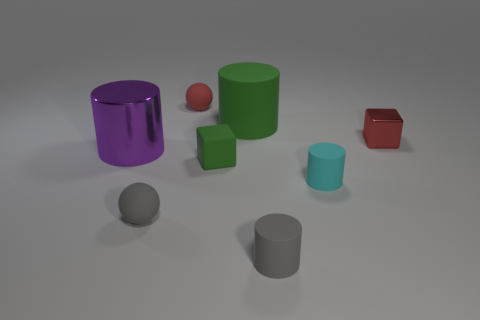Does the big shiny thing have the same shape as the tiny shiny object?
Ensure brevity in your answer.  No. What color is the matte cube that is the same size as the red matte sphere?
Your answer should be very brief. Green. The other cyan thing that is the same shape as the big matte object is what size?
Ensure brevity in your answer.  Small. The metal thing on the right side of the purple shiny thing has what shape?
Ensure brevity in your answer.  Cube. Do the big metallic object and the green rubber object behind the tiny green block have the same shape?
Offer a terse response. Yes. Are there the same number of large metallic things in front of the big purple cylinder and green rubber objects to the right of the shiny cube?
Your response must be concise. Yes. There is a rubber object that is the same color as the shiny cube; what is its shape?
Your answer should be compact. Sphere. There is a rubber thing to the left of the small red rubber thing; is its color the same as the metal thing that is behind the big purple metal object?
Ensure brevity in your answer.  No. Are there more small red things in front of the tiny red metallic object than tiny gray matte things?
Make the answer very short. No. What material is the cyan cylinder?
Offer a very short reply. Rubber. 